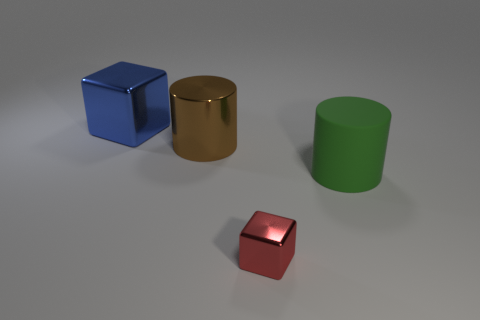Add 3 green rubber objects. How many objects exist? 7 Subtract 1 cylinders. How many cylinders are left? 1 Subtract all blue cubes. How many cubes are left? 1 Add 1 tiny red metallic objects. How many tiny red metallic objects exist? 2 Subtract 0 purple balls. How many objects are left? 4 Subtract all yellow cubes. Subtract all gray spheres. How many cubes are left? 2 Subtract all yellow cylinders. How many yellow cubes are left? 0 Subtract all large blue metallic objects. Subtract all large green matte objects. How many objects are left? 2 Add 2 red metallic things. How many red metallic things are left? 3 